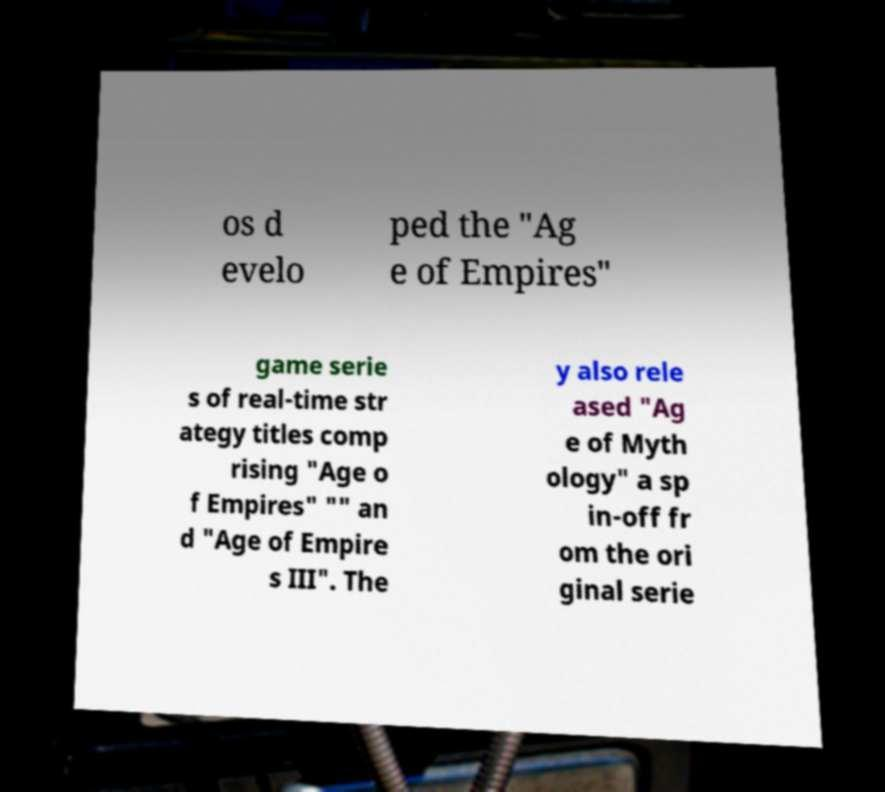Could you assist in decoding the text presented in this image and type it out clearly? os d evelo ped the "Ag e of Empires" game serie s of real-time str ategy titles comp rising "Age o f Empires" "" an d "Age of Empire s III". The y also rele ased "Ag e of Myth ology" a sp in-off fr om the ori ginal serie 